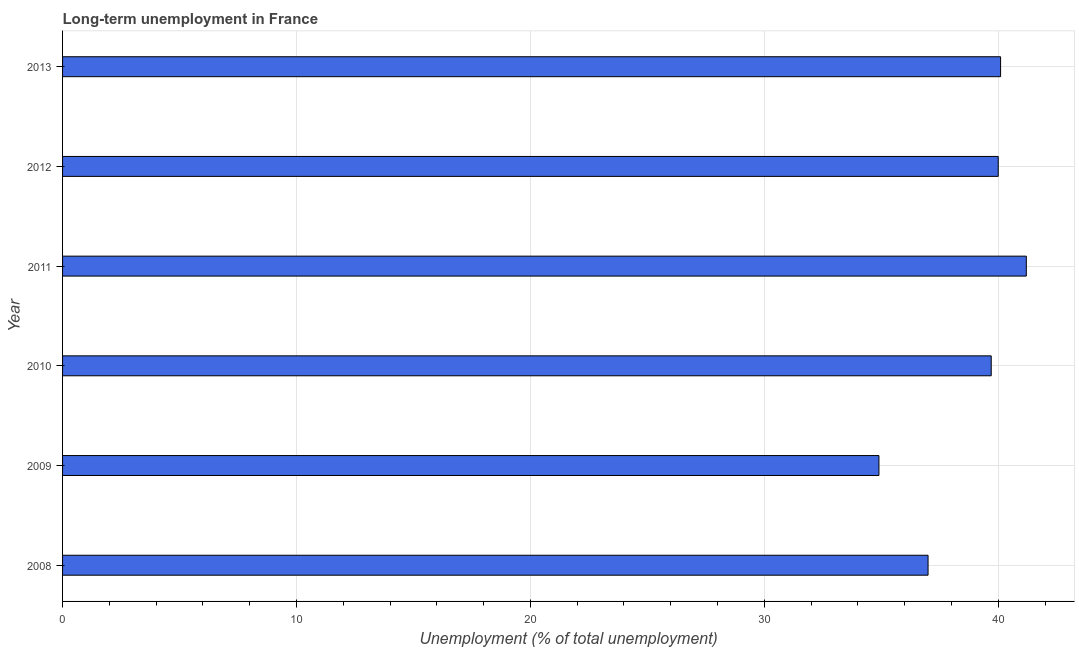Does the graph contain any zero values?
Offer a terse response. No. What is the title of the graph?
Provide a short and direct response. Long-term unemployment in France. What is the label or title of the X-axis?
Provide a succinct answer. Unemployment (% of total unemployment). What is the long-term unemployment in 2011?
Make the answer very short. 41.2. Across all years, what is the maximum long-term unemployment?
Give a very brief answer. 41.2. Across all years, what is the minimum long-term unemployment?
Provide a succinct answer. 34.9. In which year was the long-term unemployment maximum?
Offer a terse response. 2011. What is the sum of the long-term unemployment?
Make the answer very short. 232.9. What is the average long-term unemployment per year?
Your response must be concise. 38.82. What is the median long-term unemployment?
Offer a very short reply. 39.85. Do a majority of the years between 2009 and 2010 (inclusive) have long-term unemployment greater than 36 %?
Ensure brevity in your answer.  No. What is the ratio of the long-term unemployment in 2009 to that in 2011?
Give a very brief answer. 0.85. Is the difference between the long-term unemployment in 2008 and 2013 greater than the difference between any two years?
Give a very brief answer. No. Is the sum of the long-term unemployment in 2008 and 2009 greater than the maximum long-term unemployment across all years?
Your answer should be very brief. Yes. In how many years, is the long-term unemployment greater than the average long-term unemployment taken over all years?
Ensure brevity in your answer.  4. Are all the bars in the graph horizontal?
Your response must be concise. Yes. How many years are there in the graph?
Make the answer very short. 6. What is the Unemployment (% of total unemployment) of 2009?
Keep it short and to the point. 34.9. What is the Unemployment (% of total unemployment) in 2010?
Your response must be concise. 39.7. What is the Unemployment (% of total unemployment) of 2011?
Give a very brief answer. 41.2. What is the Unemployment (% of total unemployment) in 2013?
Offer a terse response. 40.1. What is the difference between the Unemployment (% of total unemployment) in 2008 and 2012?
Keep it short and to the point. -3. What is the difference between the Unemployment (% of total unemployment) in 2008 and 2013?
Your response must be concise. -3.1. What is the difference between the Unemployment (% of total unemployment) in 2009 and 2011?
Offer a terse response. -6.3. What is the difference between the Unemployment (% of total unemployment) in 2009 and 2012?
Keep it short and to the point. -5.1. What is the difference between the Unemployment (% of total unemployment) in 2010 and 2012?
Make the answer very short. -0.3. What is the difference between the Unemployment (% of total unemployment) in 2011 and 2012?
Offer a very short reply. 1.2. What is the difference between the Unemployment (% of total unemployment) in 2012 and 2013?
Your response must be concise. -0.1. What is the ratio of the Unemployment (% of total unemployment) in 2008 to that in 2009?
Keep it short and to the point. 1.06. What is the ratio of the Unemployment (% of total unemployment) in 2008 to that in 2010?
Your response must be concise. 0.93. What is the ratio of the Unemployment (% of total unemployment) in 2008 to that in 2011?
Offer a very short reply. 0.9. What is the ratio of the Unemployment (% of total unemployment) in 2008 to that in 2012?
Your answer should be very brief. 0.93. What is the ratio of the Unemployment (% of total unemployment) in 2008 to that in 2013?
Provide a short and direct response. 0.92. What is the ratio of the Unemployment (% of total unemployment) in 2009 to that in 2010?
Offer a very short reply. 0.88. What is the ratio of the Unemployment (% of total unemployment) in 2009 to that in 2011?
Provide a short and direct response. 0.85. What is the ratio of the Unemployment (% of total unemployment) in 2009 to that in 2012?
Provide a succinct answer. 0.87. What is the ratio of the Unemployment (% of total unemployment) in 2009 to that in 2013?
Keep it short and to the point. 0.87. What is the ratio of the Unemployment (% of total unemployment) in 2010 to that in 2011?
Provide a succinct answer. 0.96. What is the ratio of the Unemployment (% of total unemployment) in 2010 to that in 2013?
Keep it short and to the point. 0.99. What is the ratio of the Unemployment (% of total unemployment) in 2011 to that in 2012?
Give a very brief answer. 1.03. 